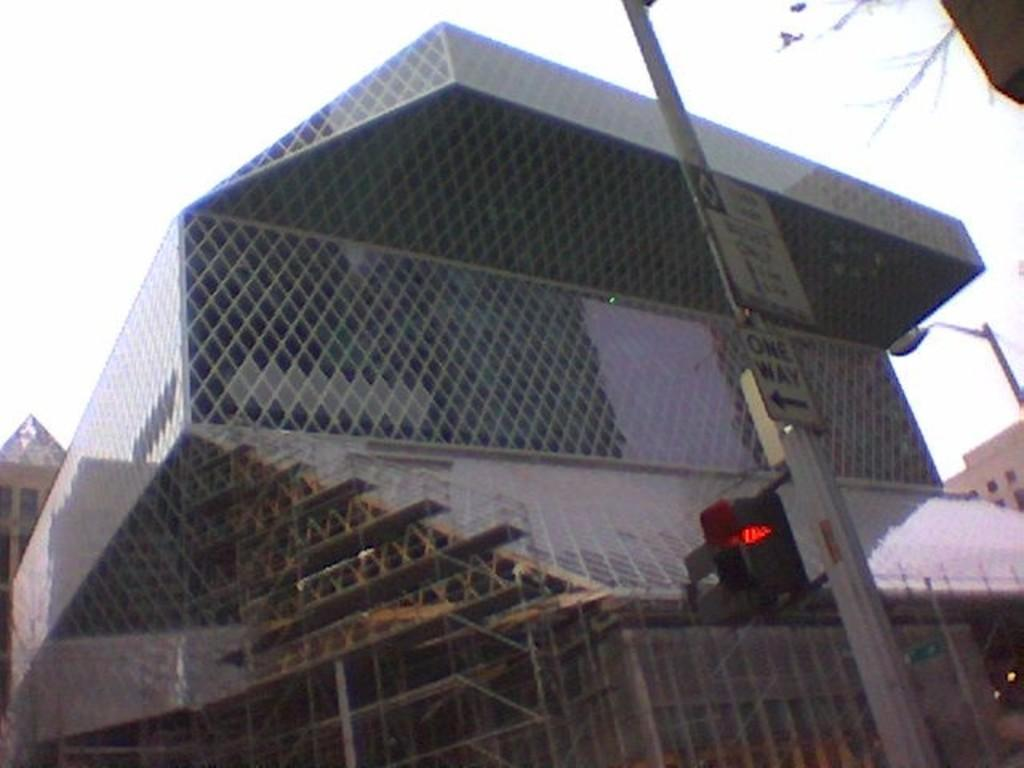What type of structures can be seen in the image? There are buildings in the image. What is attached to one of the poles in the image? There is a pole with a traffic signal light in the image. What is the purpose of the other pole in the image? The other pole has a pole light in the image. What is the condition of the sky in the image? The sky is cloudy in the image. What type of birthday celebration is happening in the image? There is no indication of a birthday celebration in the image. What arithmetic problem can be solved using the numbers on the traffic signal light? There are no numbers on the traffic signal light in the image, so no arithmetic problem can be solved. 